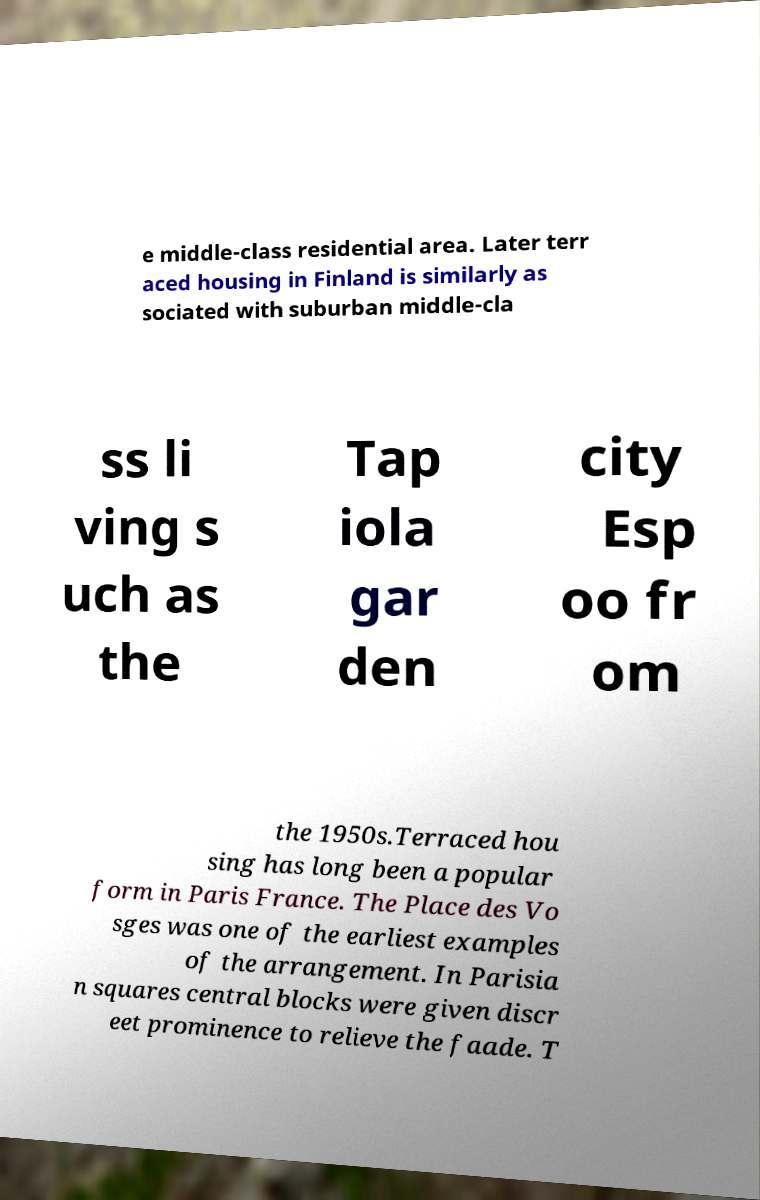For documentation purposes, I need the text within this image transcribed. Could you provide that? e middle-class residential area. Later terr aced housing in Finland is similarly as sociated with suburban middle-cla ss li ving s uch as the Tap iola gar den city Esp oo fr om the 1950s.Terraced hou sing has long been a popular form in Paris France. The Place des Vo sges was one of the earliest examples of the arrangement. In Parisia n squares central blocks were given discr eet prominence to relieve the faade. T 